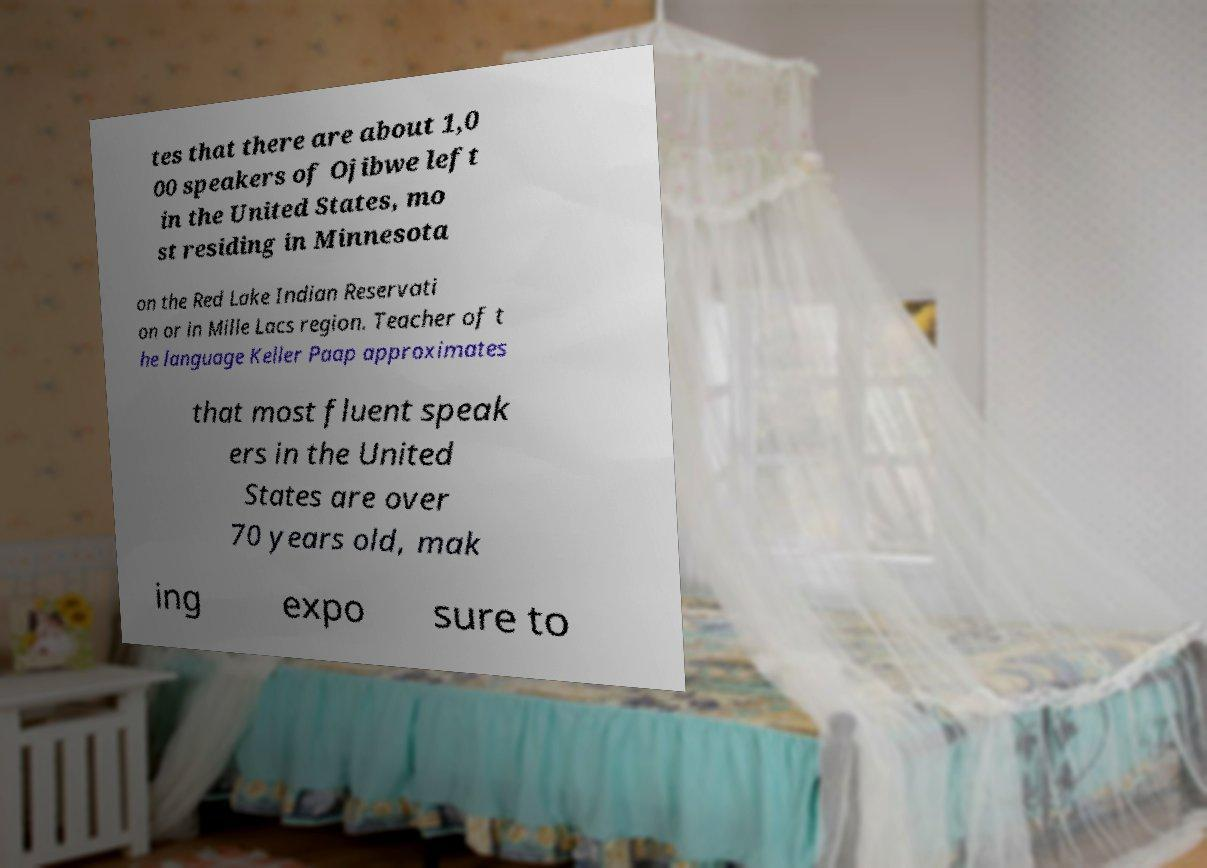For documentation purposes, I need the text within this image transcribed. Could you provide that? tes that there are about 1,0 00 speakers of Ojibwe left in the United States, mo st residing in Minnesota on the Red Lake Indian Reservati on or in Mille Lacs region. Teacher of t he language Keller Paap approximates that most fluent speak ers in the United States are over 70 years old, mak ing expo sure to 